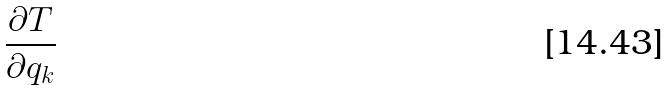Convert formula to latex. <formula><loc_0><loc_0><loc_500><loc_500>\frac { \partial T } { \partial q _ { k } }</formula> 